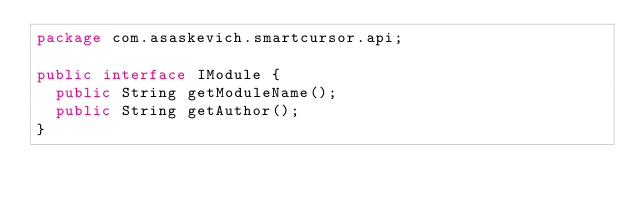Convert code to text. <code><loc_0><loc_0><loc_500><loc_500><_Java_>package com.asaskevich.smartcursor.api;

public interface IModule {
	public String getModuleName();
	public String getAuthor();
}
</code> 